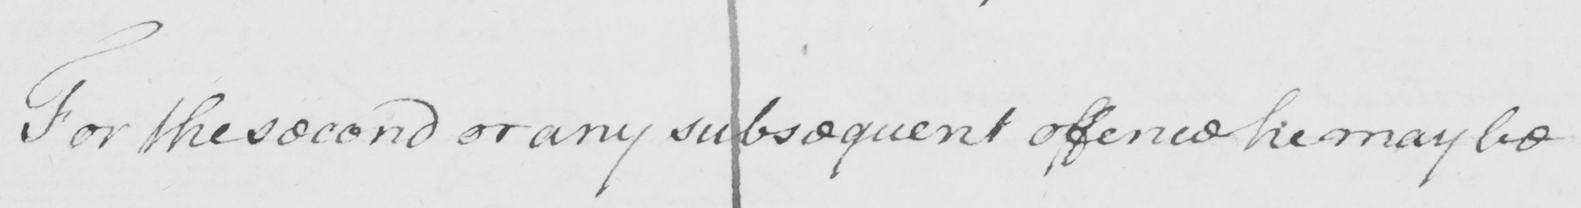Transcribe the text shown in this historical manuscript line. For the second or any subsequent offence he may be 